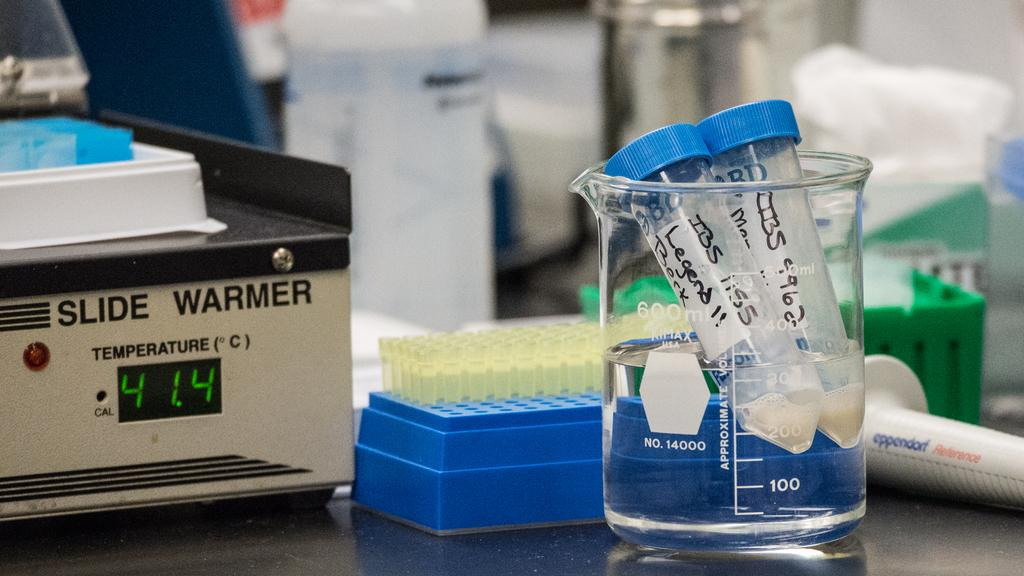<image>
Render a clear and concise summary of the photo. A slide warmer machine in a science lab is set to 41.4 degrees celsious 